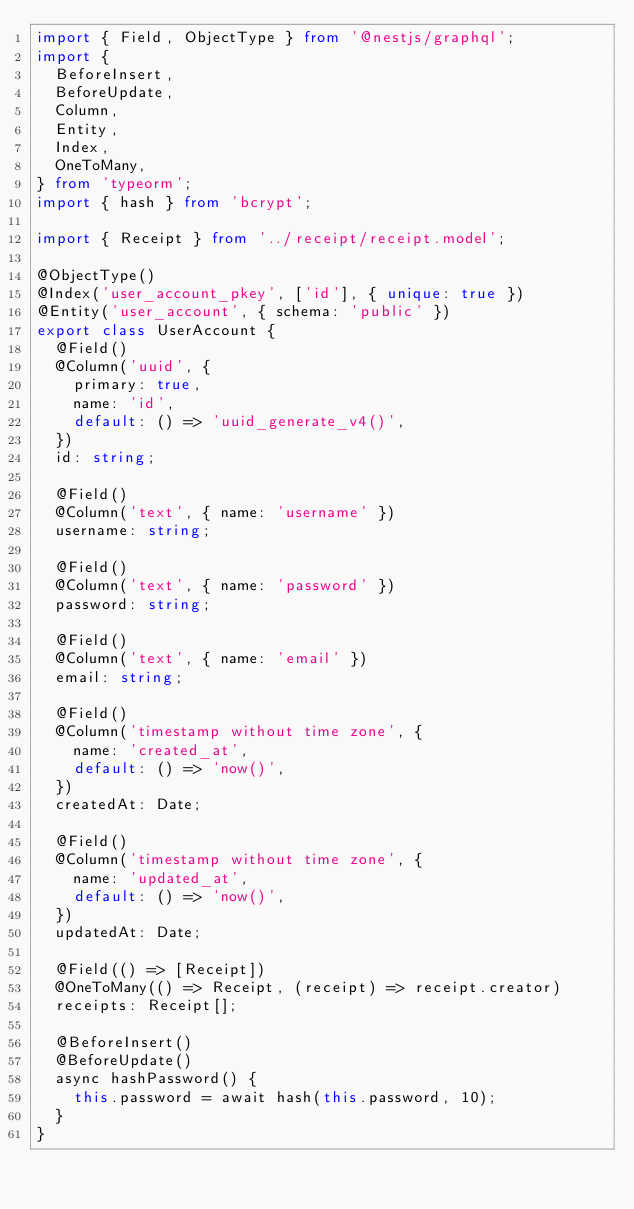Convert code to text. <code><loc_0><loc_0><loc_500><loc_500><_TypeScript_>import { Field, ObjectType } from '@nestjs/graphql';
import {
  BeforeInsert,
  BeforeUpdate,
  Column,
  Entity,
  Index,
  OneToMany,
} from 'typeorm';
import { hash } from 'bcrypt';

import { Receipt } from '../receipt/receipt.model';

@ObjectType()
@Index('user_account_pkey', ['id'], { unique: true })
@Entity('user_account', { schema: 'public' })
export class UserAccount {
  @Field()
  @Column('uuid', {
    primary: true,
    name: 'id',
    default: () => 'uuid_generate_v4()',
  })
  id: string;

  @Field()
  @Column('text', { name: 'username' })
  username: string;

  @Field()
  @Column('text', { name: 'password' })
  password: string;

  @Field()
  @Column('text', { name: 'email' })
  email: string;

  @Field()
  @Column('timestamp without time zone', {
    name: 'created_at',
    default: () => 'now()',
  })
  createdAt: Date;

  @Field()
  @Column('timestamp without time zone', {
    name: 'updated_at',
    default: () => 'now()',
  })
  updatedAt: Date;

  @Field(() => [Receipt])
  @OneToMany(() => Receipt, (receipt) => receipt.creator)
  receipts: Receipt[];

  @BeforeInsert()
  @BeforeUpdate()
  async hashPassword() {
    this.password = await hash(this.password, 10);
  }
}
</code> 